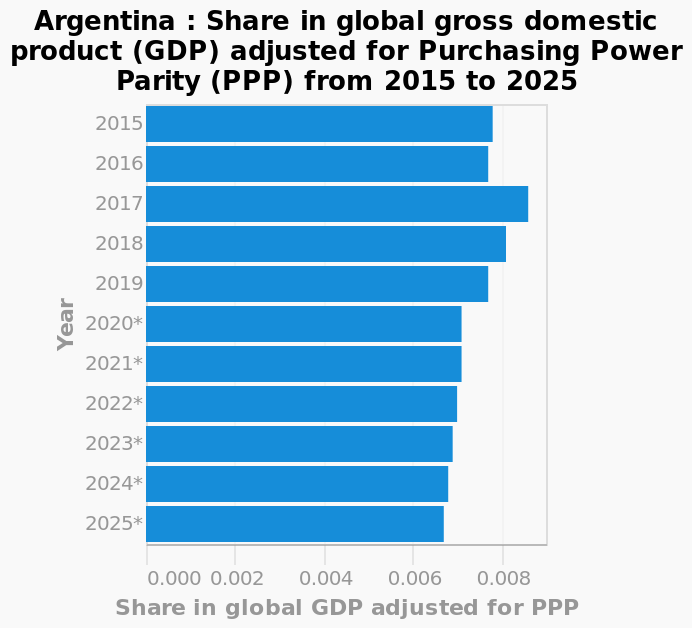<image>
please describe the details of the chart Argentina : Share in global gross domestic product (GDP) adjusted for Purchasing Power Parity (PPP) from 2015 to 2025 is a bar diagram. The x-axis plots Share in global GDP adjusted for PPP while the y-axis measures Year. 